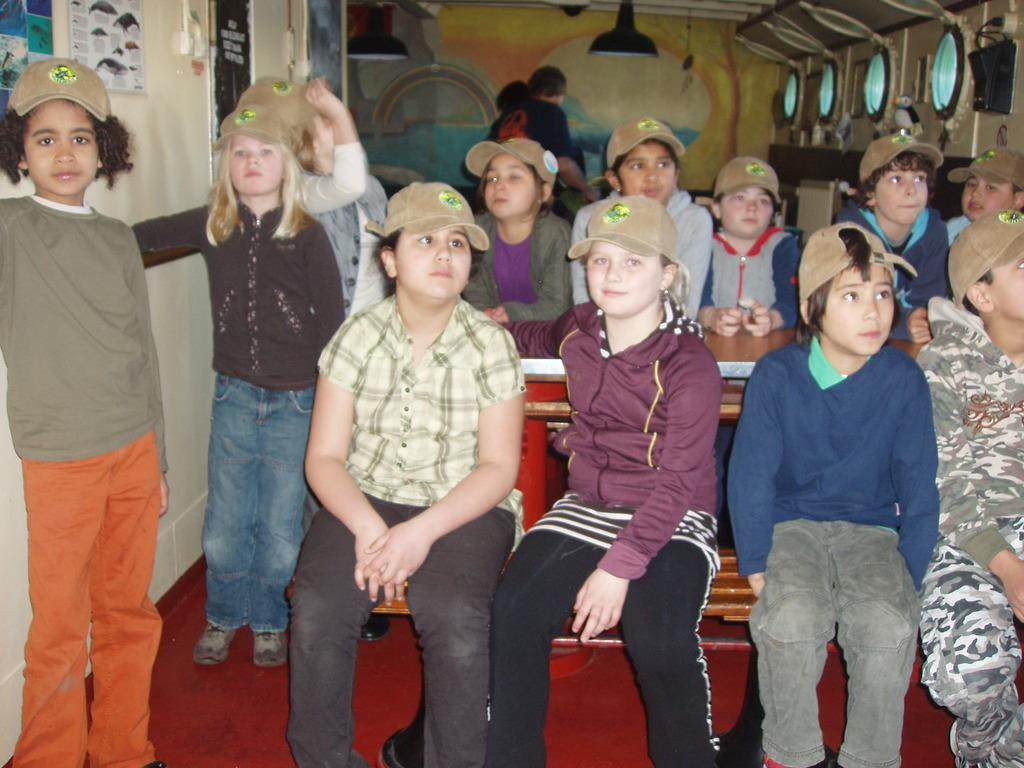What is the main subject of the image? The main subject of the image is a group of small boys and girls. What are the children doing in the image? The children are sitting on benches and smiling. What are they doing while sitting on the benches? The children are posing for the camera. What can be seen in the background of the image? There is a painted wall visible in the background, along with hanging lights. What type of clock is hanging on the neck of one of the children in the image? There is no clock visible in the image, nor is there any indication that a child is wearing a clock around their neck. 